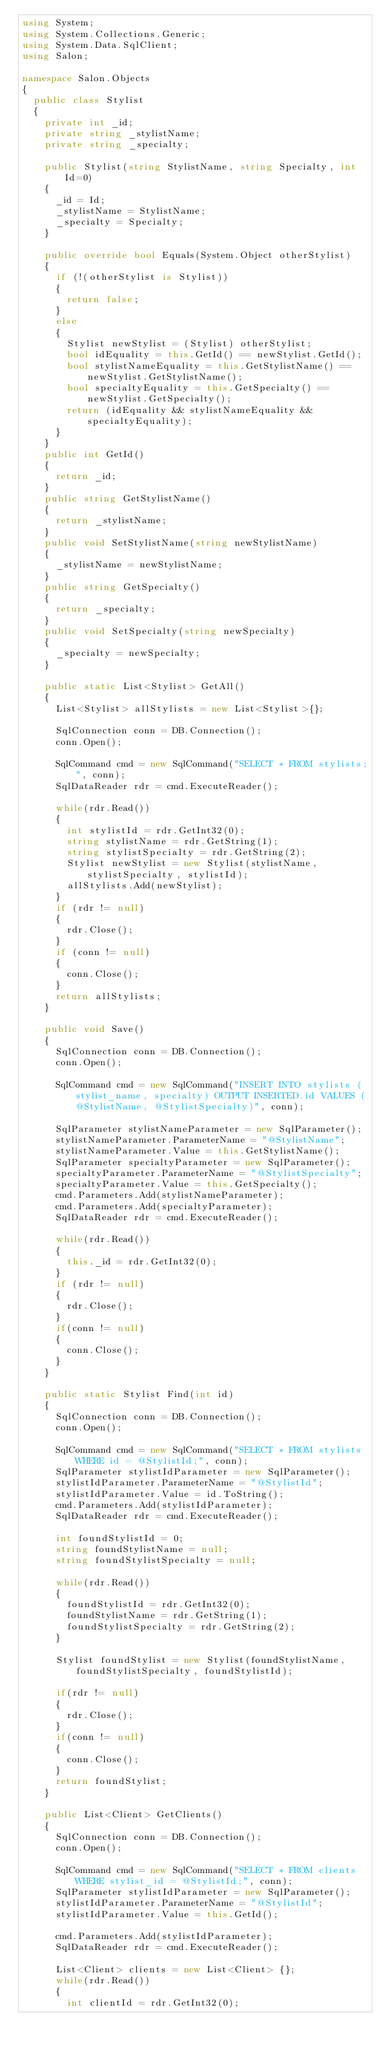<code> <loc_0><loc_0><loc_500><loc_500><_C#_>using System;
using System.Collections.Generic;
using System.Data.SqlClient;
using Salon;

namespace Salon.Objects
{
  public class Stylist
  {
    private int _id;
    private string _stylistName;
    private string _specialty;

    public Stylist(string StylistName, string Specialty, int Id=0)
    {
      _id = Id;
      _stylistName = StylistName;
      _specialty = Specialty;
    }

    public override bool Equals(System.Object otherStylist)
    {
      if (!(otherStylist is Stylist))
      {
        return false;
      }
      else
      {
        Stylist newStylist = (Stylist) otherStylist;
        bool idEquality = this.GetId() == newStylist.GetId();
        bool stylistNameEquality = this.GetStylistName() == newStylist.GetStylistName();
        bool specialtyEquality = this.GetSpecialty() == newStylist.GetSpecialty();
        return (idEquality && stylistNameEquality && specialtyEquality);
      }
    }
    public int GetId()
    {
      return _id;
    }
    public string GetStylistName()
    {
      return _stylistName;
    }
    public void SetStylistName(string newStylistName)
    {
      _stylistName = newStylistName;
    }
    public string GetSpecialty()
    {
      return _specialty;
    }
    public void SetSpecialty(string newSpecialty)
    {
      _specialty = newSpecialty;
    }

    public static List<Stylist> GetAll()
    {
      List<Stylist> allStylists = new List<Stylist>{};

      SqlConnection conn = DB.Connection();
      conn.Open();

      SqlCommand cmd = new SqlCommand("SELECT * FROM stylists;", conn);
      SqlDataReader rdr = cmd.ExecuteReader();

      while(rdr.Read())
      {
        int stylistId = rdr.GetInt32(0);
        string stylistName = rdr.GetString(1);
        string stylistSpecialty = rdr.GetString(2);
        Stylist newStylist = new Stylist(stylistName, stylistSpecialty, stylistId);
        allStylists.Add(newStylist);
      }
      if (rdr != null)
      {
        rdr.Close();
      }
      if (conn != null)
      {
        conn.Close();
      }
      return allStylists;
    }

    public void Save()
    {
      SqlConnection conn = DB.Connection();
      conn.Open();

      SqlCommand cmd = new SqlCommand("INSERT INTO stylists (stylist_name, specialty) OUTPUT INSERTED.id VALUES (@StylistName, @StylistSpecialty)", conn);

      SqlParameter stylistNameParameter = new SqlParameter();
      stylistNameParameter.ParameterName = "@StylistName";
      stylistNameParameter.Value = this.GetStylistName();
      SqlParameter specialtyParameter = new SqlParameter();
      specialtyParameter.ParameterName = "@StylistSpecialty";
      specialtyParameter.Value = this.GetSpecialty();
      cmd.Parameters.Add(stylistNameParameter);
      cmd.Parameters.Add(specialtyParameter);
      SqlDataReader rdr = cmd.ExecuteReader();

      while(rdr.Read())
      {
        this._id = rdr.GetInt32(0);
      }
      if (rdr != null)
      {
        rdr.Close();
      }
      if(conn != null)
      {
        conn.Close();
      }
    }

    public static Stylist Find(int id)
    {
      SqlConnection conn = DB.Connection();
      conn.Open();

      SqlCommand cmd = new SqlCommand("SELECT * FROM stylists WHERE id = @StylistId;", conn);
      SqlParameter stylistIdParameter = new SqlParameter();
      stylistIdParameter.ParameterName = "@StylistId";
      stylistIdParameter.Value = id.ToString();
      cmd.Parameters.Add(stylistIdParameter);
      SqlDataReader rdr = cmd.ExecuteReader();

      int foundStylistId = 0;
      string foundStylistName = null;
      string foundStylistSpecialty = null;

      while(rdr.Read())
      {
        foundStylistId = rdr.GetInt32(0);
        foundStylistName = rdr.GetString(1);
        foundStylistSpecialty = rdr.GetString(2);
      }

      Stylist foundStylist = new Stylist(foundStylistName, foundStylistSpecialty, foundStylistId);

      if(rdr != null)
      {
        rdr.Close();
      }
      if(conn != null)
      {
        conn.Close();
      }
      return foundStylist;
    }

    public List<Client> GetClients()
    {
      SqlConnection conn = DB.Connection();
      conn.Open();

      SqlCommand cmd = new SqlCommand("SELECT * FROM clients WHERE stylist_id = @StylistId;", conn);
      SqlParameter stylistIdParameter = new SqlParameter();
      stylistIdParameter.ParameterName = "@StylistId";
      stylistIdParameter.Value = this.GetId();

      cmd.Parameters.Add(stylistIdParameter);
      SqlDataReader rdr = cmd.ExecuteReader();

      List<Client> clients = new List<Client> {};
      while(rdr.Read())
      {
        int clientId = rdr.GetInt32(0);</code> 